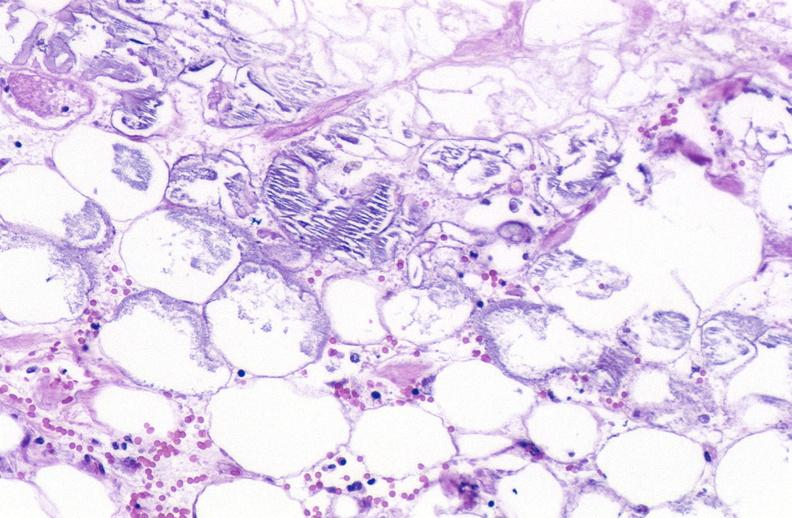does endocervical polyp show pancreatic fat necrosis?
Answer the question using a single word or phrase. No 